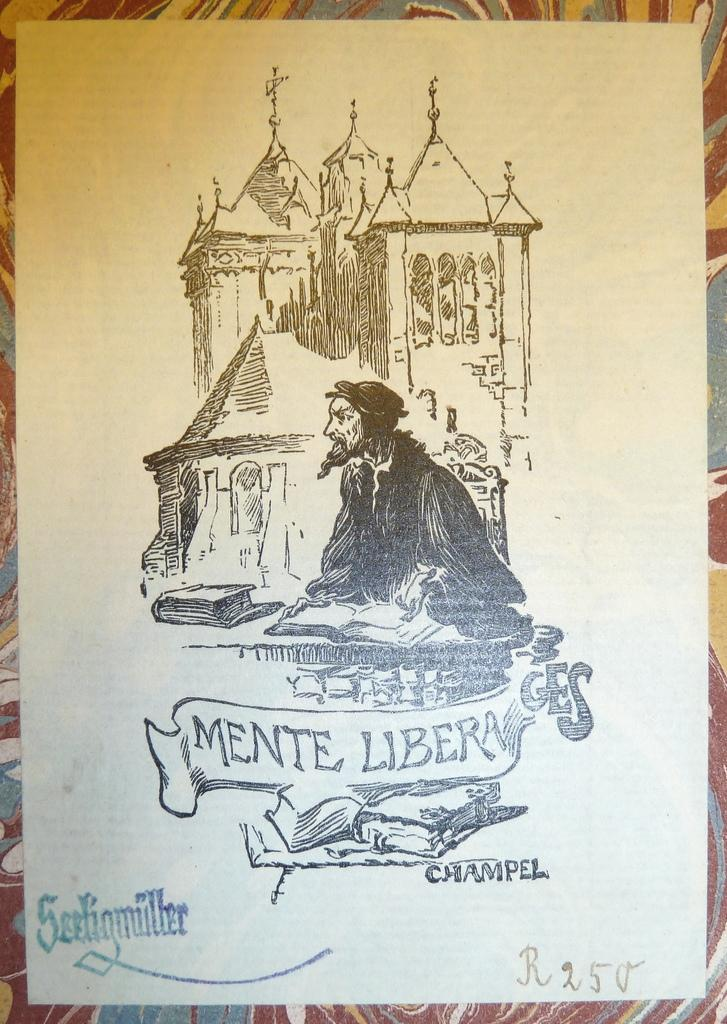What is the main subject of the poster in the image? There is a person depicted on the poster in the image. What else can be seen on the poster besides the person? There is a building depicted on the poster in the image. Is there any text on the poster? Yes, there is text at the bottom of the poster in the image. What type of beef is being served at the event depicted on the poster? There is no mention of beef or any event in the image, as the facts only describe the poster's contents. 